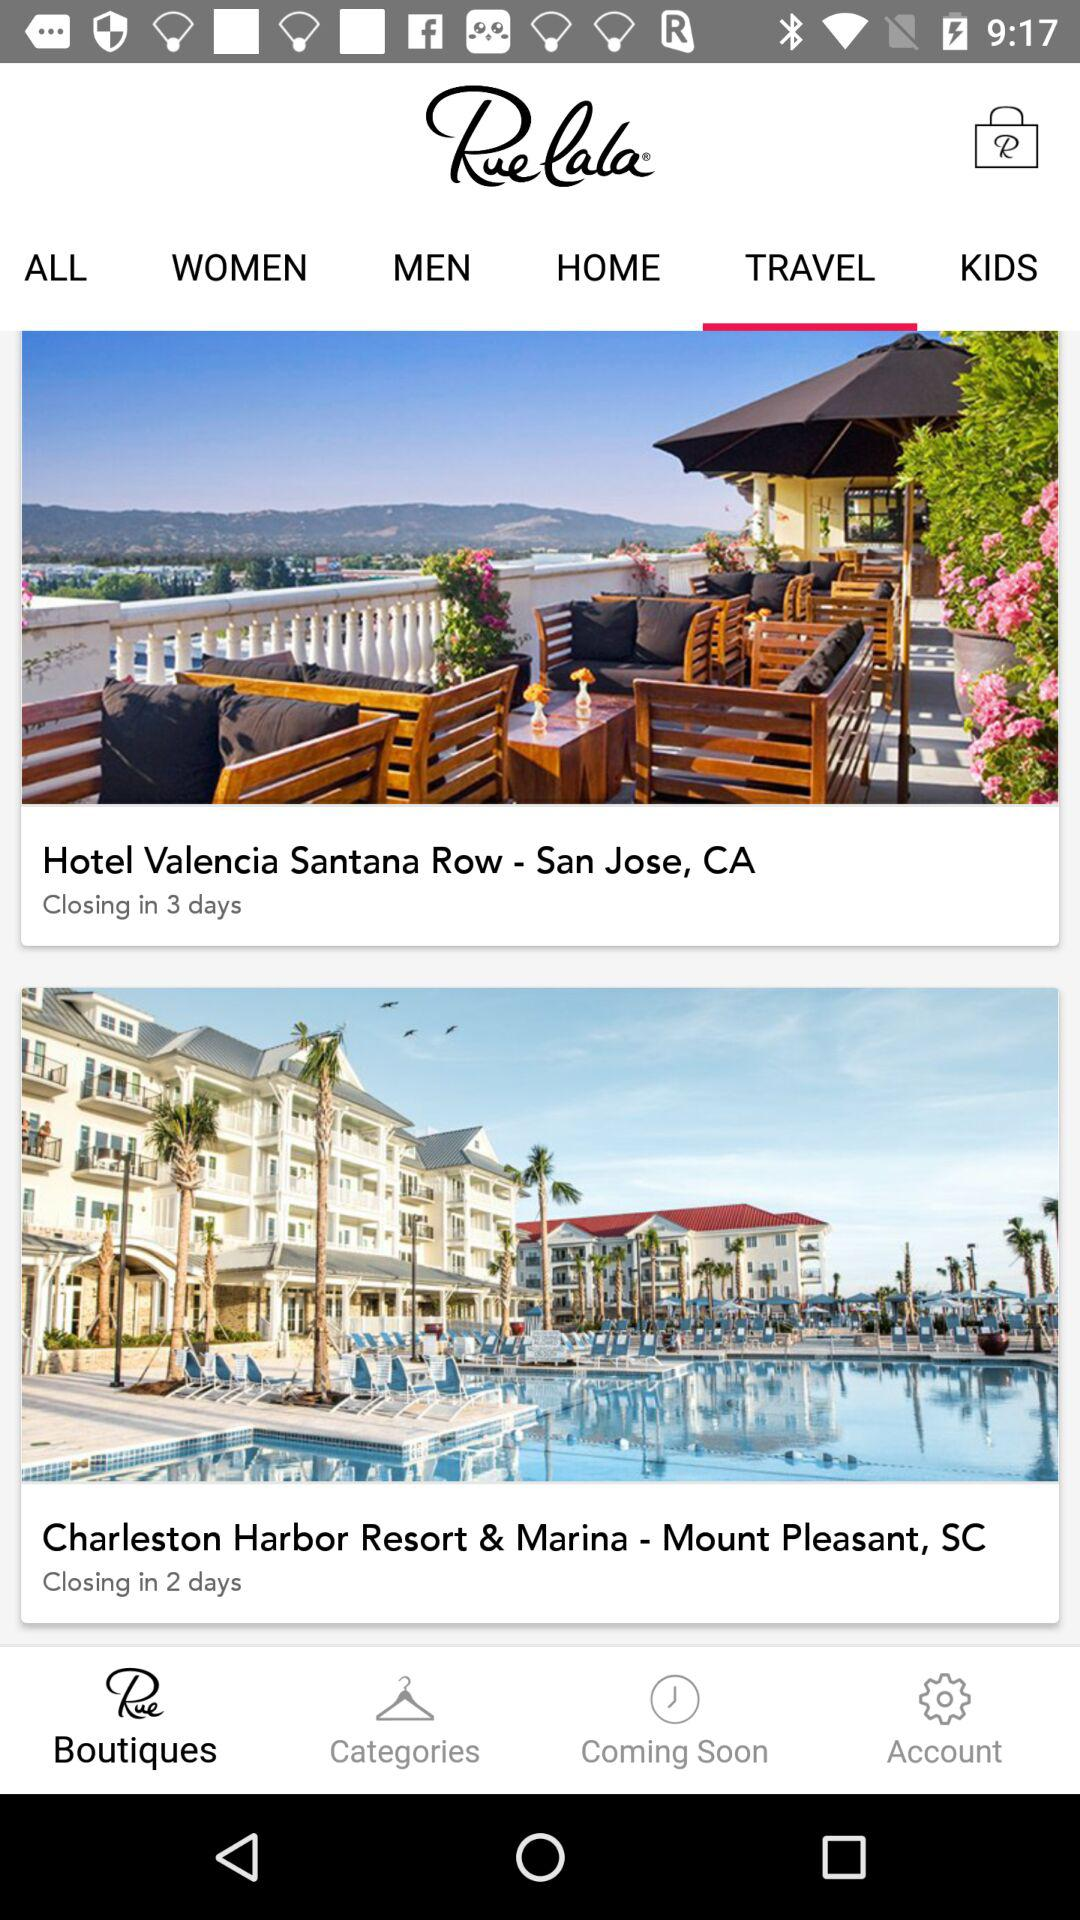In how many days will the bookings for "Hotel Valencia Santana Row" close? The bookings for "Hotel Valencia Santana Row" will close in 3 days. 